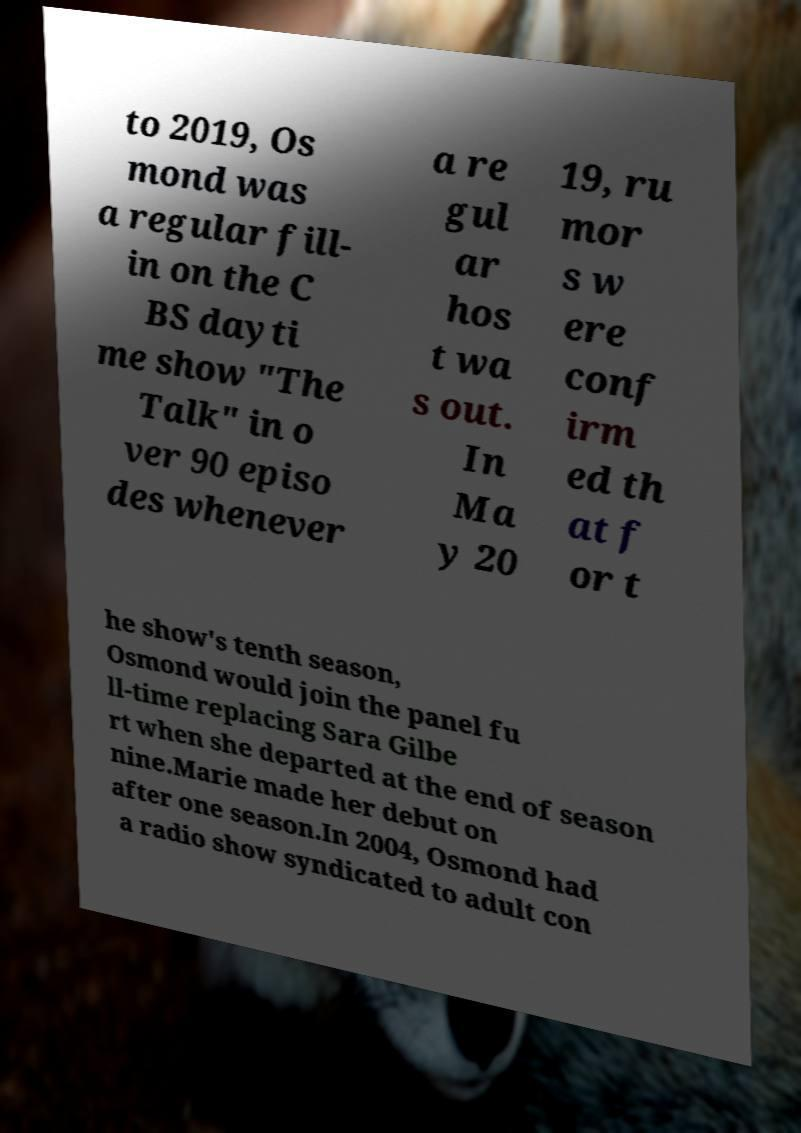Could you assist in decoding the text presented in this image and type it out clearly? to 2019, Os mond was a regular fill- in on the C BS dayti me show "The Talk" in o ver 90 episo des whenever a re gul ar hos t wa s out. In Ma y 20 19, ru mor s w ere conf irm ed th at f or t he show's tenth season, Osmond would join the panel fu ll-time replacing Sara Gilbe rt when she departed at the end of season nine.Marie made her debut on after one season.In 2004, Osmond had a radio show syndicated to adult con 